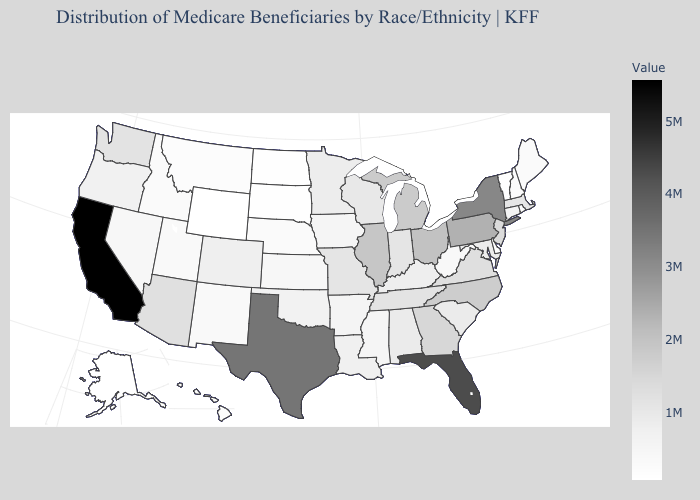Which states hav the highest value in the South?
Concise answer only. Florida. Which states have the lowest value in the Northeast?
Write a very short answer. Vermont. Does Alaska have a lower value than Pennsylvania?
Concise answer only. Yes. Does Florida have the highest value in the South?
Be succinct. Yes. 